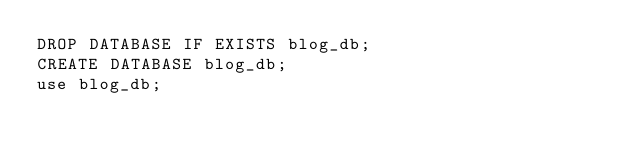Convert code to text. <code><loc_0><loc_0><loc_500><loc_500><_SQL_>DROP DATABASE IF EXISTS blog_db;
CREATE DATABASE blog_db;
use blog_db;
</code> 